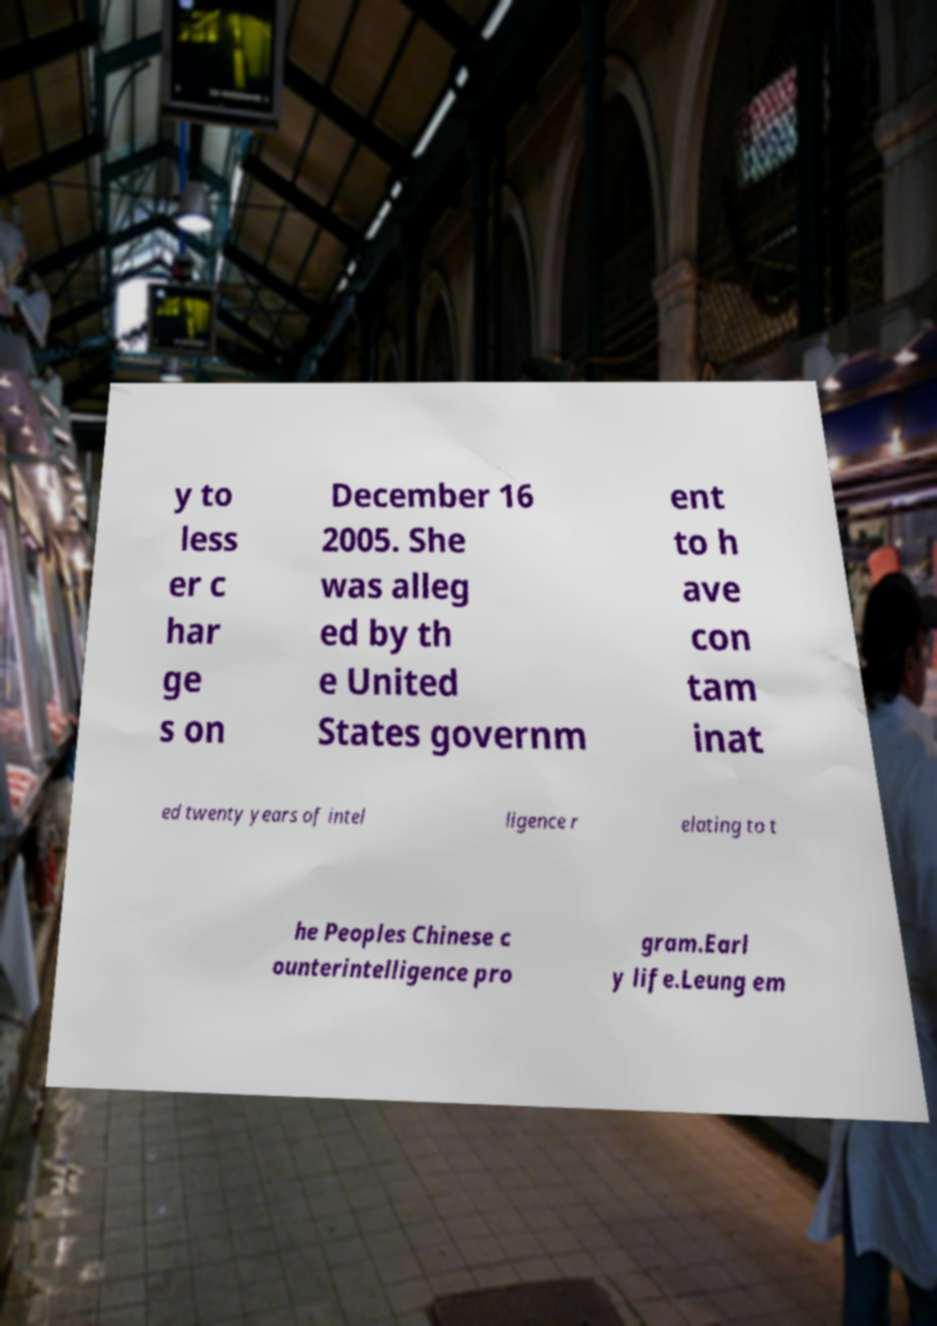For documentation purposes, I need the text within this image transcribed. Could you provide that? y to less er c har ge s on December 16 2005. She was alleg ed by th e United States governm ent to h ave con tam inat ed twenty years of intel ligence r elating to t he Peoples Chinese c ounterintelligence pro gram.Earl y life.Leung em 